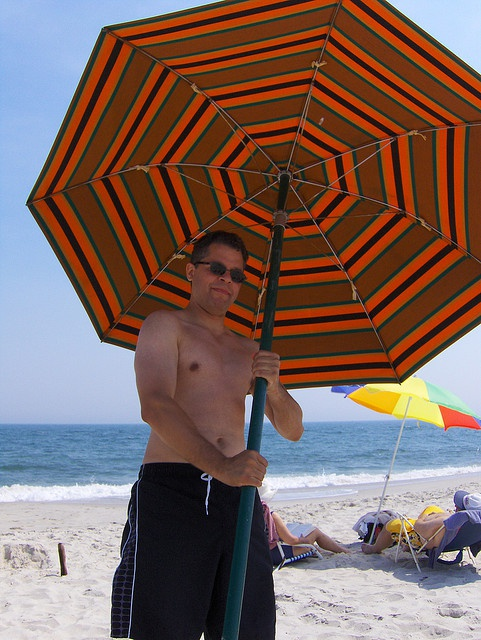Describe the objects in this image and their specific colors. I can see umbrella in lightblue, maroon, black, and brown tones, people in lightblue, black, brown, and maroon tones, umbrella in lightblue, khaki, and gold tones, chair in lightblue, navy, gray, black, and purple tones, and people in lightblue, gray, lightgray, and blue tones in this image. 